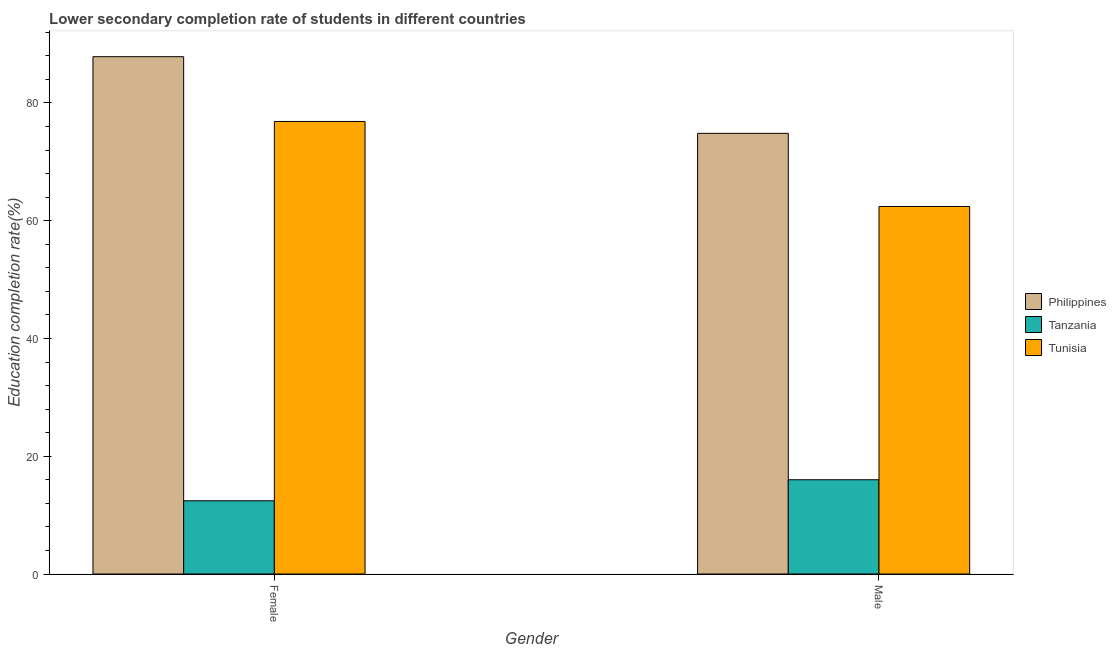How many different coloured bars are there?
Your answer should be compact. 3. How many groups of bars are there?
Keep it short and to the point. 2. How many bars are there on the 2nd tick from the left?
Offer a terse response. 3. How many bars are there on the 2nd tick from the right?
Give a very brief answer. 3. What is the education completion rate of male students in Tunisia?
Offer a very short reply. 62.41. Across all countries, what is the maximum education completion rate of male students?
Make the answer very short. 74.83. Across all countries, what is the minimum education completion rate of male students?
Offer a terse response. 16.01. In which country was the education completion rate of male students maximum?
Your response must be concise. Philippines. In which country was the education completion rate of female students minimum?
Your answer should be very brief. Tanzania. What is the total education completion rate of male students in the graph?
Offer a terse response. 153.26. What is the difference between the education completion rate of male students in Tanzania and that in Philippines?
Ensure brevity in your answer.  -58.83. What is the difference between the education completion rate of female students in Philippines and the education completion rate of male students in Tanzania?
Your answer should be very brief. 71.84. What is the average education completion rate of male students per country?
Your answer should be compact. 51.09. What is the difference between the education completion rate of male students and education completion rate of female students in Tunisia?
Ensure brevity in your answer.  -14.44. What is the ratio of the education completion rate of female students in Tanzania to that in Tunisia?
Ensure brevity in your answer.  0.16. What does the 2nd bar from the left in Female represents?
Provide a succinct answer. Tanzania. What does the 2nd bar from the right in Female represents?
Your response must be concise. Tanzania. How many bars are there?
Ensure brevity in your answer.  6. Are all the bars in the graph horizontal?
Give a very brief answer. No. How many countries are there in the graph?
Make the answer very short. 3. What is the difference between two consecutive major ticks on the Y-axis?
Ensure brevity in your answer.  20. Are the values on the major ticks of Y-axis written in scientific E-notation?
Ensure brevity in your answer.  No. Does the graph contain grids?
Make the answer very short. No. Where does the legend appear in the graph?
Provide a succinct answer. Center right. How many legend labels are there?
Provide a succinct answer. 3. What is the title of the graph?
Give a very brief answer. Lower secondary completion rate of students in different countries. Does "Zimbabwe" appear as one of the legend labels in the graph?
Make the answer very short. No. What is the label or title of the Y-axis?
Your answer should be very brief. Education completion rate(%). What is the Education completion rate(%) of Philippines in Female?
Ensure brevity in your answer.  87.85. What is the Education completion rate(%) of Tanzania in Female?
Offer a very short reply. 12.43. What is the Education completion rate(%) in Tunisia in Female?
Provide a succinct answer. 76.85. What is the Education completion rate(%) in Philippines in Male?
Provide a succinct answer. 74.83. What is the Education completion rate(%) in Tanzania in Male?
Ensure brevity in your answer.  16.01. What is the Education completion rate(%) in Tunisia in Male?
Ensure brevity in your answer.  62.41. Across all Gender, what is the maximum Education completion rate(%) of Philippines?
Your response must be concise. 87.85. Across all Gender, what is the maximum Education completion rate(%) of Tanzania?
Give a very brief answer. 16.01. Across all Gender, what is the maximum Education completion rate(%) in Tunisia?
Your response must be concise. 76.85. Across all Gender, what is the minimum Education completion rate(%) in Philippines?
Make the answer very short. 74.83. Across all Gender, what is the minimum Education completion rate(%) of Tanzania?
Offer a very short reply. 12.43. Across all Gender, what is the minimum Education completion rate(%) of Tunisia?
Ensure brevity in your answer.  62.41. What is the total Education completion rate(%) of Philippines in the graph?
Ensure brevity in your answer.  162.69. What is the total Education completion rate(%) in Tanzania in the graph?
Provide a short and direct response. 28.44. What is the total Education completion rate(%) in Tunisia in the graph?
Make the answer very short. 139.27. What is the difference between the Education completion rate(%) of Philippines in Female and that in Male?
Your response must be concise. 13.02. What is the difference between the Education completion rate(%) of Tanzania in Female and that in Male?
Your answer should be very brief. -3.58. What is the difference between the Education completion rate(%) of Tunisia in Female and that in Male?
Provide a short and direct response. 14.44. What is the difference between the Education completion rate(%) in Philippines in Female and the Education completion rate(%) in Tanzania in Male?
Give a very brief answer. 71.84. What is the difference between the Education completion rate(%) of Philippines in Female and the Education completion rate(%) of Tunisia in Male?
Offer a terse response. 25.44. What is the difference between the Education completion rate(%) in Tanzania in Female and the Education completion rate(%) in Tunisia in Male?
Ensure brevity in your answer.  -49.98. What is the average Education completion rate(%) of Philippines per Gender?
Your response must be concise. 81.34. What is the average Education completion rate(%) of Tanzania per Gender?
Provide a short and direct response. 14.22. What is the average Education completion rate(%) of Tunisia per Gender?
Offer a terse response. 69.63. What is the difference between the Education completion rate(%) in Philippines and Education completion rate(%) in Tanzania in Female?
Make the answer very short. 75.42. What is the difference between the Education completion rate(%) of Philippines and Education completion rate(%) of Tunisia in Female?
Your answer should be compact. 11. What is the difference between the Education completion rate(%) of Tanzania and Education completion rate(%) of Tunisia in Female?
Provide a short and direct response. -64.42. What is the difference between the Education completion rate(%) of Philippines and Education completion rate(%) of Tanzania in Male?
Offer a terse response. 58.83. What is the difference between the Education completion rate(%) in Philippines and Education completion rate(%) in Tunisia in Male?
Provide a short and direct response. 12.42. What is the difference between the Education completion rate(%) of Tanzania and Education completion rate(%) of Tunisia in Male?
Keep it short and to the point. -46.41. What is the ratio of the Education completion rate(%) of Philippines in Female to that in Male?
Provide a short and direct response. 1.17. What is the ratio of the Education completion rate(%) of Tanzania in Female to that in Male?
Provide a short and direct response. 0.78. What is the ratio of the Education completion rate(%) of Tunisia in Female to that in Male?
Make the answer very short. 1.23. What is the difference between the highest and the second highest Education completion rate(%) of Philippines?
Ensure brevity in your answer.  13.02. What is the difference between the highest and the second highest Education completion rate(%) of Tanzania?
Your answer should be compact. 3.58. What is the difference between the highest and the second highest Education completion rate(%) of Tunisia?
Offer a terse response. 14.44. What is the difference between the highest and the lowest Education completion rate(%) in Philippines?
Ensure brevity in your answer.  13.02. What is the difference between the highest and the lowest Education completion rate(%) of Tanzania?
Make the answer very short. 3.58. What is the difference between the highest and the lowest Education completion rate(%) in Tunisia?
Your answer should be compact. 14.44. 